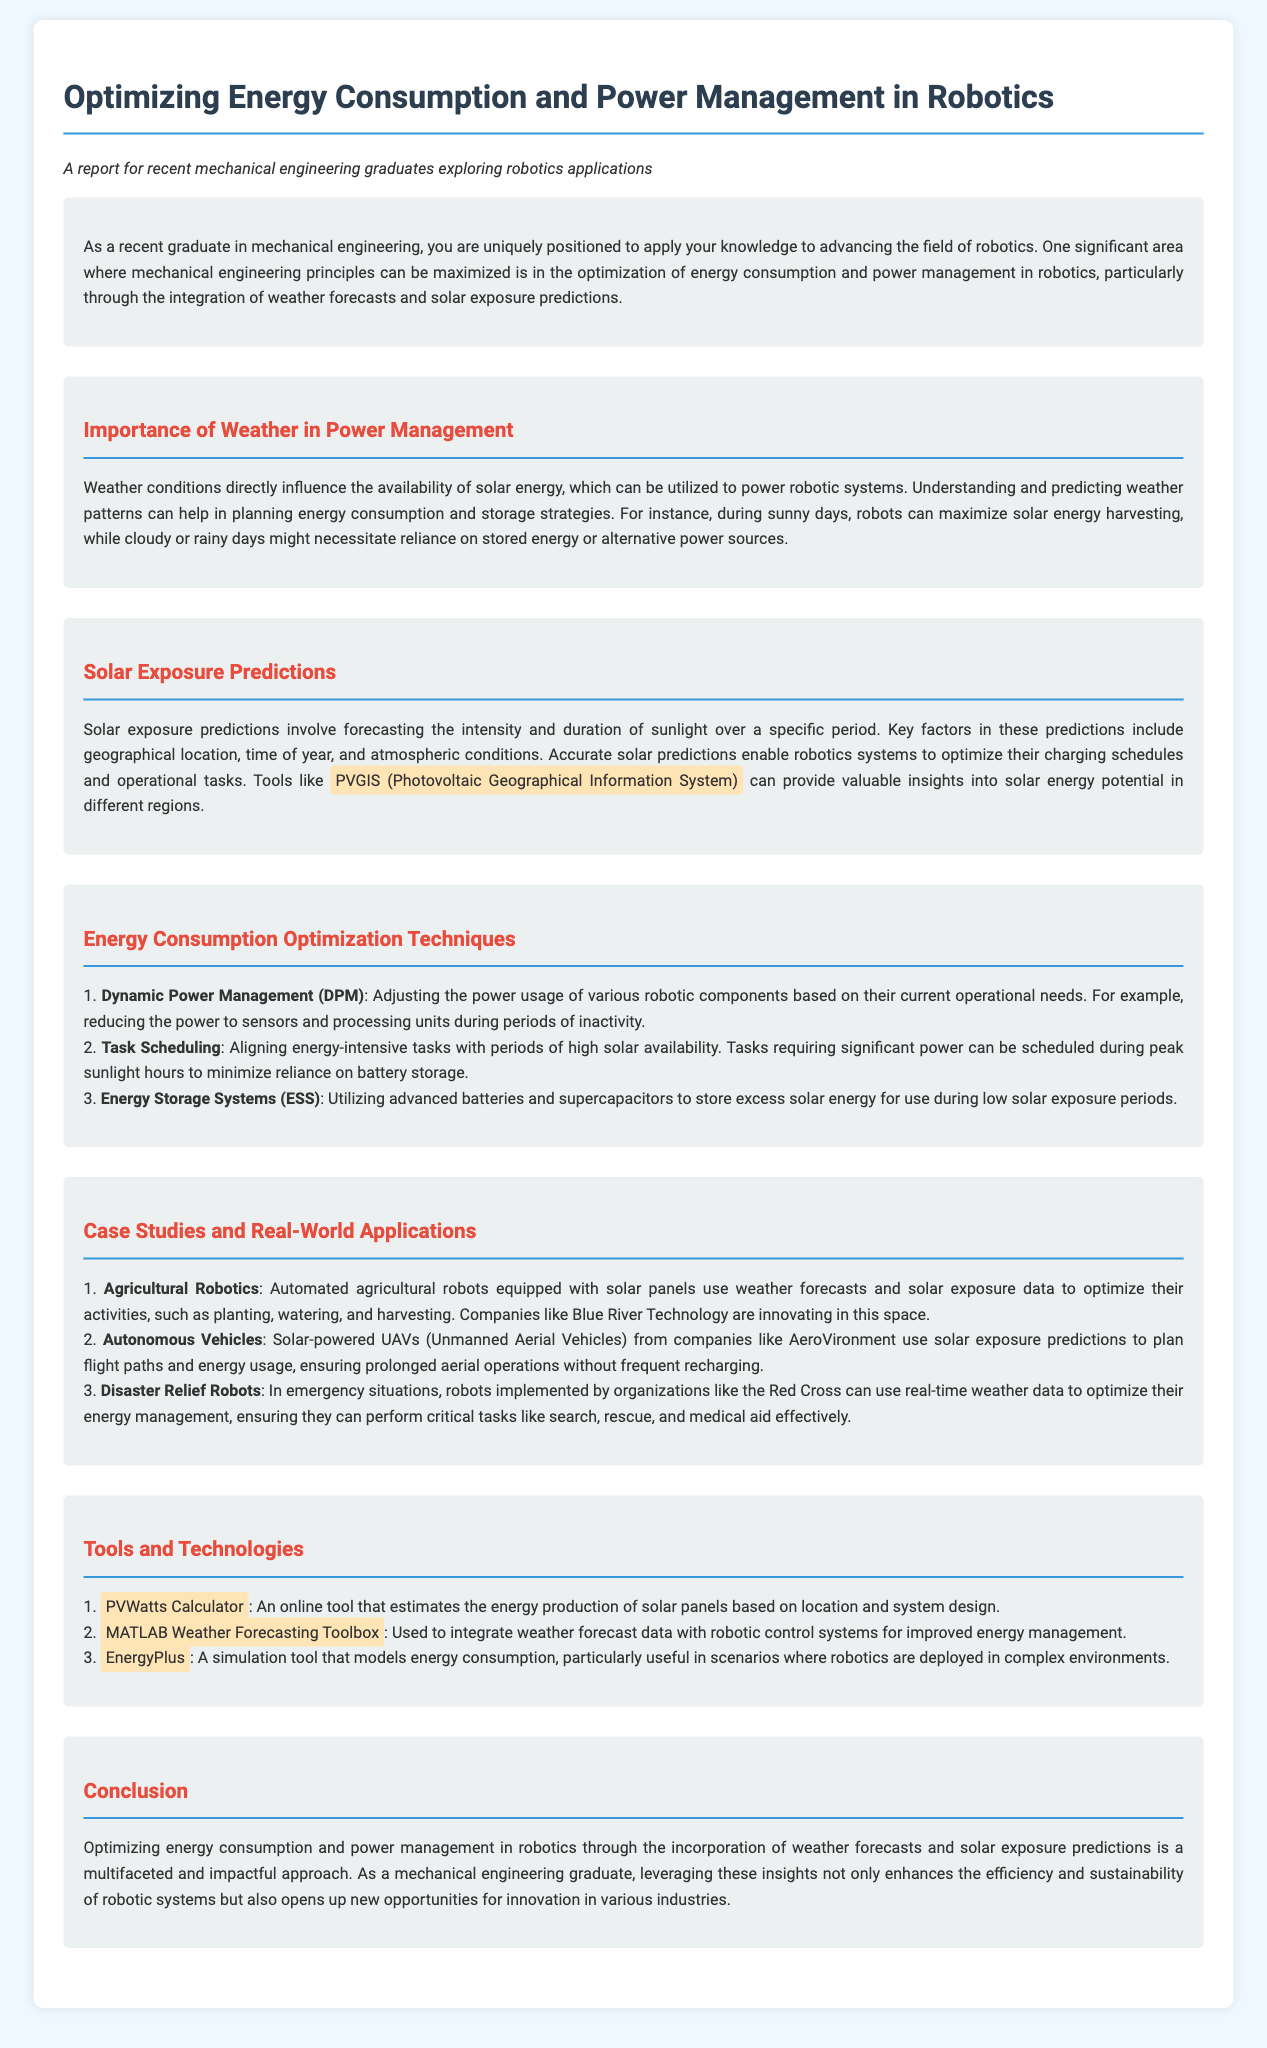What is the main topic of the report? The main topic of the report is about optimizing energy consumption and power management in robotics through the integration of weather forecasts and solar exposure predictions.
Answer: optimizing energy consumption and power management in robotics What tool is suggested for solar energy potential insights? The report mentions PVGIS, which stands for Photovoltaic Geographical Information System, as a tool for solar energy potential insights.
Answer: PVGIS What does Dynamic Power Management (DPM) involve? Dynamic Power Management (DPM) involves adjusting the power usage of various robotic components based on their current operational needs.
Answer: adjusting power usage What is one application of solar-powered UAVs? The report states that solar-powered UAVs use solar exposure predictions to plan flight paths and energy usage.
Answer: plan flight paths How can weather conditions affect energy strategies in robotics? Weather conditions influence the availability of solar energy, driving strategies for energy consumption and storage.
Answer: influence solar energy availability What is one of the listed energy optimization techniques? The report lists Task Scheduling as one of the energy optimization techniques.
Answer: Task Scheduling Which agricultural technology company is mentioned in the report? Blue River Technology is the agricultural technology company mentioned in the report.
Answer: Blue River Technology What does EnergyPlus model? EnergyPlus is a simulation tool that models energy consumption, particularly useful for robotics in complex environments.
Answer: energy consumption What is the purpose of the MATLAB Weather Forecasting Toolbox? The purpose of the MATLAB Weather Forecasting Toolbox is to integrate weather forecast data with robotic control systems for improved energy management.
Answer: integrate weather forecast data 